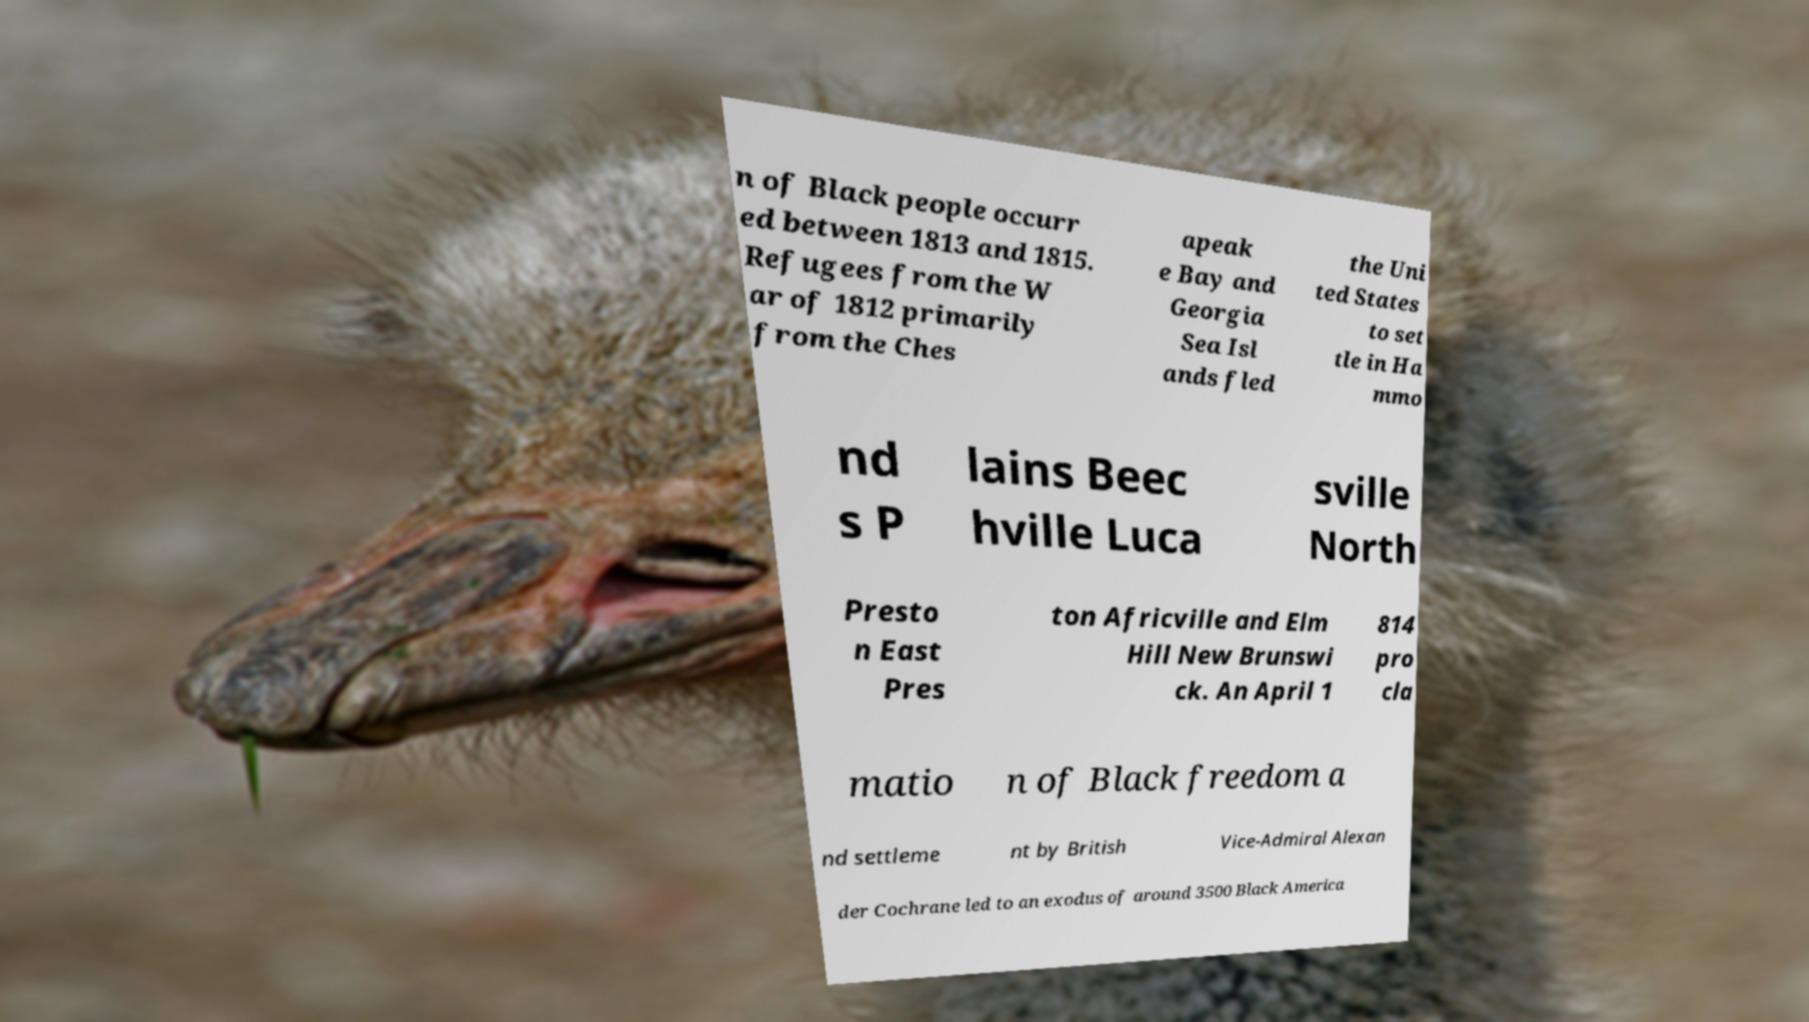Could you extract and type out the text from this image? n of Black people occurr ed between 1813 and 1815. Refugees from the W ar of 1812 primarily from the Ches apeak e Bay and Georgia Sea Isl ands fled the Uni ted States to set tle in Ha mmo nd s P lains Beec hville Luca sville North Presto n East Pres ton Africville and Elm Hill New Brunswi ck. An April 1 814 pro cla matio n of Black freedom a nd settleme nt by British Vice-Admiral Alexan der Cochrane led to an exodus of around 3500 Black America 